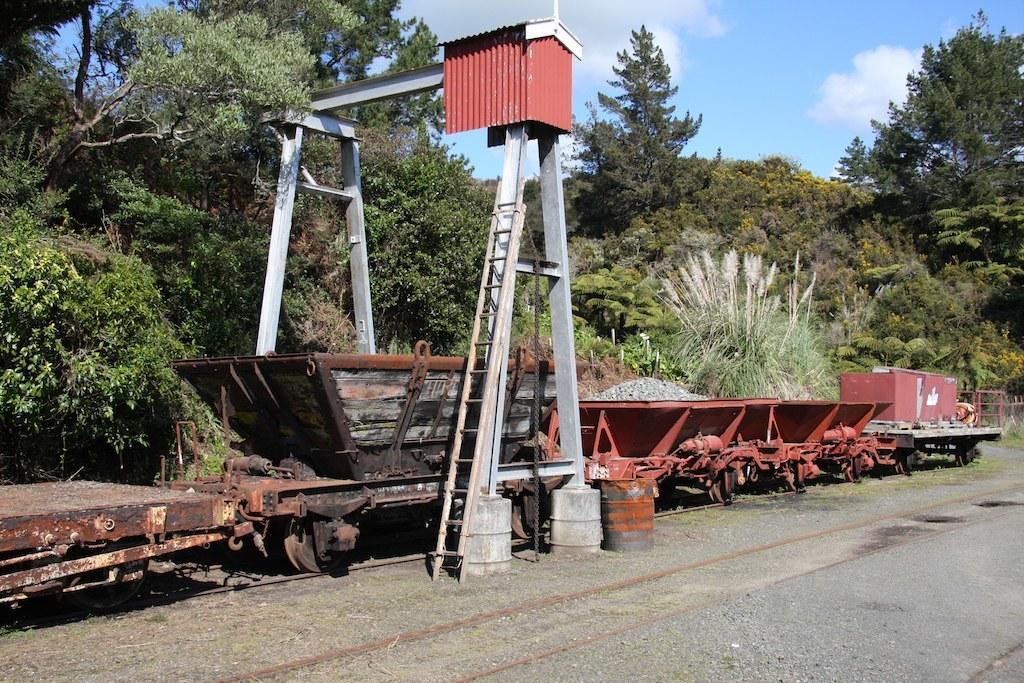Can you describe this image briefly? In this image I can see railway tracks and here I can see railway trolleys. I can also see number of trees, clouds, the sky and here I can see ladder. 